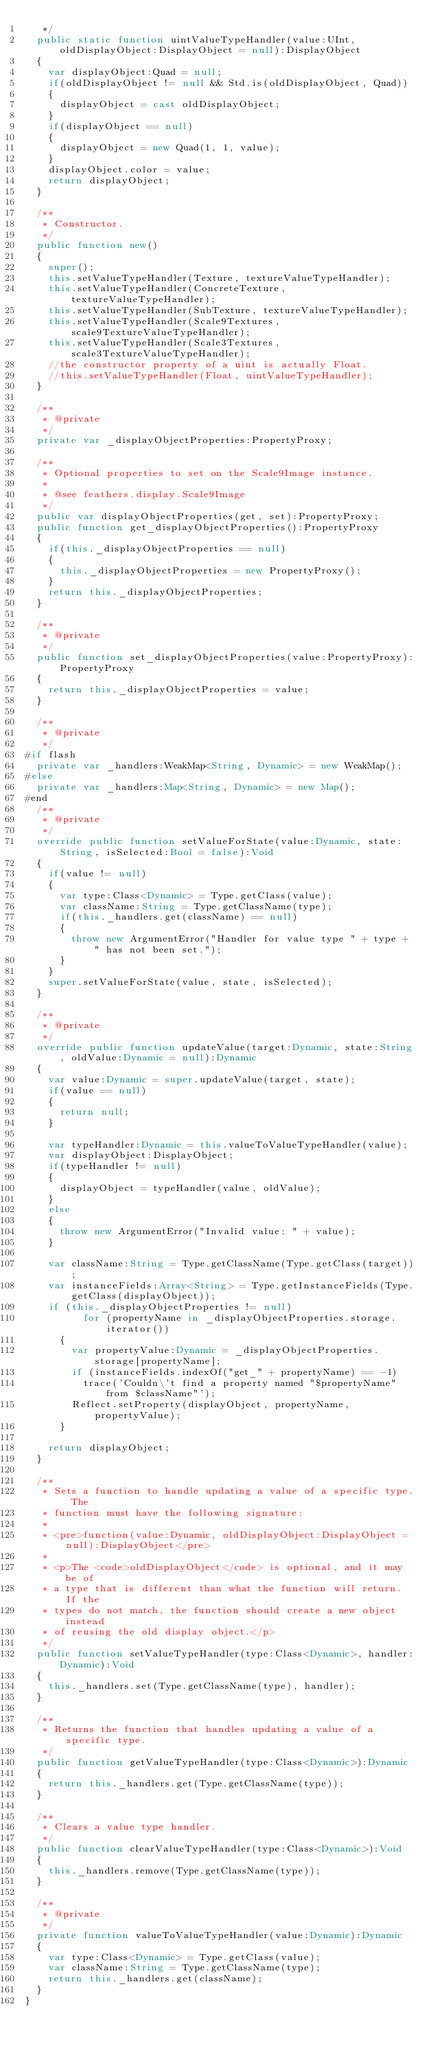<code> <loc_0><loc_0><loc_500><loc_500><_Haxe_>	 */
	public static function uintValueTypeHandler(value:UInt, oldDisplayObject:DisplayObject = null):DisplayObject
	{
		var displayObject:Quad = null;
		if(oldDisplayObject != null && Std.is(oldDisplayObject, Quad))
		{
			displayObject = cast oldDisplayObject;
		}
		if(displayObject == null)
		{
			displayObject = new Quad(1, 1, value);
		}
		displayObject.color = value;
		return displayObject;
	}

	/**
	 * Constructor.
	 */
	public function new()
	{
		super();
		this.setValueTypeHandler(Texture, textureValueTypeHandler);
		this.setValueTypeHandler(ConcreteTexture, textureValueTypeHandler);
		this.setValueTypeHandler(SubTexture, textureValueTypeHandler);
		this.setValueTypeHandler(Scale9Textures, scale9TextureValueTypeHandler);
		this.setValueTypeHandler(Scale3Textures, scale3TextureValueTypeHandler);
		//the constructor property of a uint is actually Float.
		//this.setValueTypeHandler(Float, uintValueTypeHandler);
	}

	/**
	 * @private
	 */
	private var _displayObjectProperties:PropertyProxy;

	/**
	 * Optional properties to set on the Scale9Image instance.
	 *
	 * @see feathers.display.Scale9Image
	 */
	public var displayObjectProperties(get, set):PropertyProxy;
	public function get_displayObjectProperties():PropertyProxy
	{
		if(this._displayObjectProperties == null)
		{
			this._displayObjectProperties = new PropertyProxy();
		}
		return this._displayObjectProperties;
	}

	/**
	 * @private
	 */
	public function set_displayObjectProperties(value:PropertyProxy):PropertyProxy
	{
		return this._displayObjectProperties = value;
	}

	/**
	 * @private
	 */
#if flash
	private var _handlers:WeakMap<String, Dynamic> = new WeakMap();
#else
	private var _handlers:Map<String, Dynamic> = new Map();
#end
	/**
	 * @private
	 */
	override public function setValueForState(value:Dynamic, state:String, isSelected:Bool = false):Void
	{
		if(value != null)
		{
			var type:Class<Dynamic> = Type.getClass(value);
			var className:String = Type.getClassName(type);
			if(this._handlers.get(className) == null)
			{
				throw new ArgumentError("Handler for value type " + type + " has not been set.");
			}
		}
		super.setValueForState(value, state, isSelected);
	}

	/**
	 * @private
	 */
	override public function updateValue(target:Dynamic, state:String, oldValue:Dynamic = null):Dynamic
	{
		var value:Dynamic = super.updateValue(target, state);
		if(value == null)
		{
			return null;
		}

		var typeHandler:Dynamic = this.valueToValueTypeHandler(value);
		var displayObject:DisplayObject;
		if(typeHandler != null)
		{
			displayObject = typeHandler(value, oldValue);
		}
		else
		{
			throw new ArgumentError("Invalid value: " + value);
		}

		var className:String = Type.getClassName(Type.getClass(target));
		var instanceFields:Array<String> = Type.getInstanceFields(Type.getClass(displayObject));
		if (this._displayObjectProperties != null)
        	for (propertyName in _displayObjectProperties.storage.iterator())
			{
				var propertyValue:Dynamic = _displayObjectProperties.storage[propertyName];
				if (instanceFields.indexOf("get_" + propertyName) == -1)
					trace('Couldn\'t find a property named "$propertyName" from $className"');
				Reflect.setProperty(displayObject, propertyName, propertyValue);
			}

		return displayObject;
	}

	/**
	 * Sets a function to handle updating a value of a specific type. The
	 * function must have the following signature:
	 *
	 * <pre>function(value:Dynamic, oldDisplayObject:DisplayObject = null):DisplayObject</pre>
	 *
	 * <p>The <code>oldDisplayObject</code> is optional, and it may be of
	 * a type that is different than what the function will return. If the
	 * types do not match, the function should create a new object instead
	 * of reusing the old display object.</p>
	 */
	public function setValueTypeHandler(type:Class<Dynamic>, handler:Dynamic):Void
	{
		this._handlers.set(Type.getClassName(type), handler);
	}

	/**
	 * Returns the function that handles updating a value of a specific type.
	 */
	public function getValueTypeHandler(type:Class<Dynamic>):Dynamic
	{
		return this._handlers.get(Type.getClassName(type));
	}

	/**
	 * Clears a value type handler.
	 */
	public function clearValueTypeHandler(type:Class<Dynamic>):Void
	{
		this._handlers.remove(Type.getClassName(type));
	}

	/**
	 * @private
	 */
	private function valueToValueTypeHandler(value:Dynamic):Dynamic
	{
		var type:Class<Dynamic> = Type.getClass(value);
		var className:String = Type.getClassName(type);
		return this._handlers.get(className);
	}
}
</code> 